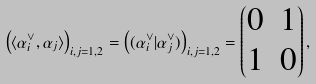<formula> <loc_0><loc_0><loc_500><loc_500>\left ( \langle \alpha ^ { \vee } _ { i } , \alpha _ { j } \rangle \right ) _ { i , j = 1 , 2 } = \left ( ( \alpha ^ { \vee } _ { i } | \alpha ^ { \vee } _ { j } ) \right ) _ { i , j = 1 , 2 } = \begin{pmatrix} 0 & 1 \\ 1 & 0 \end{pmatrix} ,</formula> 